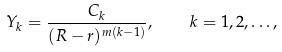<formula> <loc_0><loc_0><loc_500><loc_500>Y _ { k } = \frac { C _ { k } } { ( R - r ) ^ { m ( k - 1 ) } } , \quad k = 1 , 2 , \dots ,</formula> 